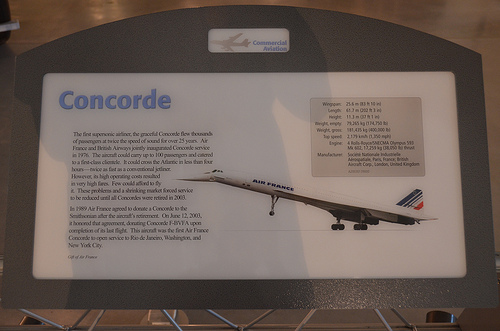<image>
Is there a plane on the plaque? Yes. Looking at the image, I can see the plane is positioned on top of the plaque, with the plaque providing support. Where is the plane in relation to the ground? Is it on the ground? No. The plane is not positioned on the ground. They may be near each other, but the plane is not supported by or resting on top of the ground. 